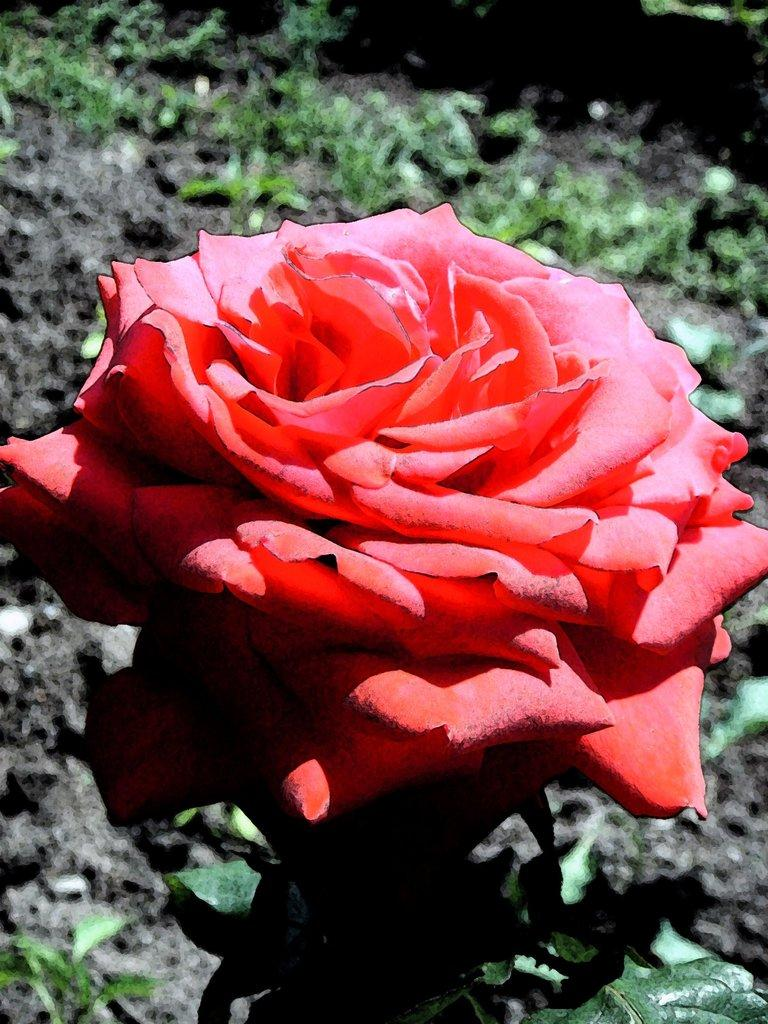What is the main subject in the foreground of the image? There is a red rose in the foreground of the image. What can be seen in the background of the image? The ground is visible in the background of the image. What color is the owner's throat in the image? There is no owner present in the image, and therefore no throat to observe. 